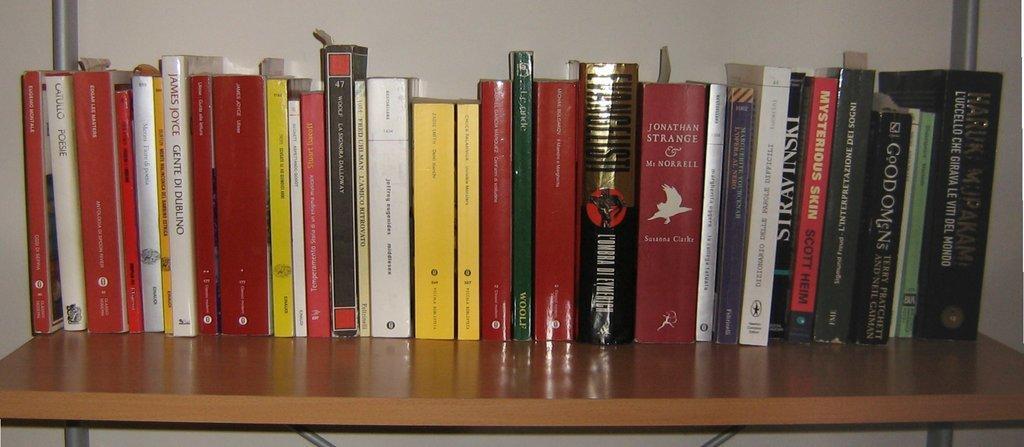Describe this image in one or two sentences. In the picture there are many books present on the shelf, behind the books there is a wall. 